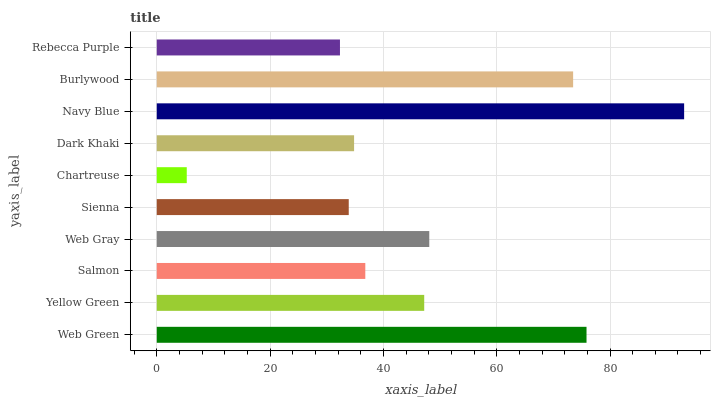Is Chartreuse the minimum?
Answer yes or no. Yes. Is Navy Blue the maximum?
Answer yes or no. Yes. Is Yellow Green the minimum?
Answer yes or no. No. Is Yellow Green the maximum?
Answer yes or no. No. Is Web Green greater than Yellow Green?
Answer yes or no. Yes. Is Yellow Green less than Web Green?
Answer yes or no. Yes. Is Yellow Green greater than Web Green?
Answer yes or no. No. Is Web Green less than Yellow Green?
Answer yes or no. No. Is Yellow Green the high median?
Answer yes or no. Yes. Is Salmon the low median?
Answer yes or no. Yes. Is Burlywood the high median?
Answer yes or no. No. Is Web Green the low median?
Answer yes or no. No. 